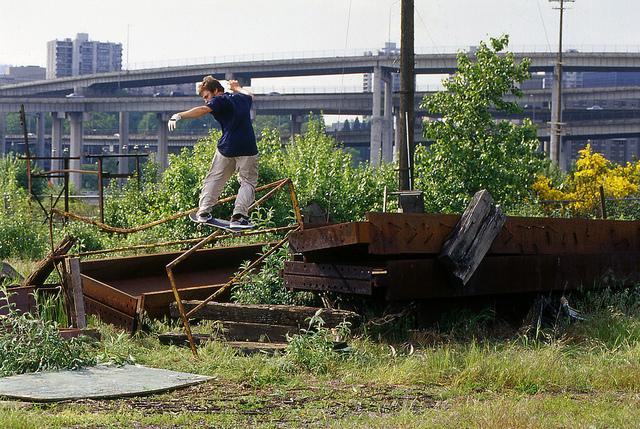What is this man doing?
Keep it brief. Skateboarding. Is this man on top of a bridge?
Write a very short answer. No. What color is the man's shirt?
Short answer required. Blue. 